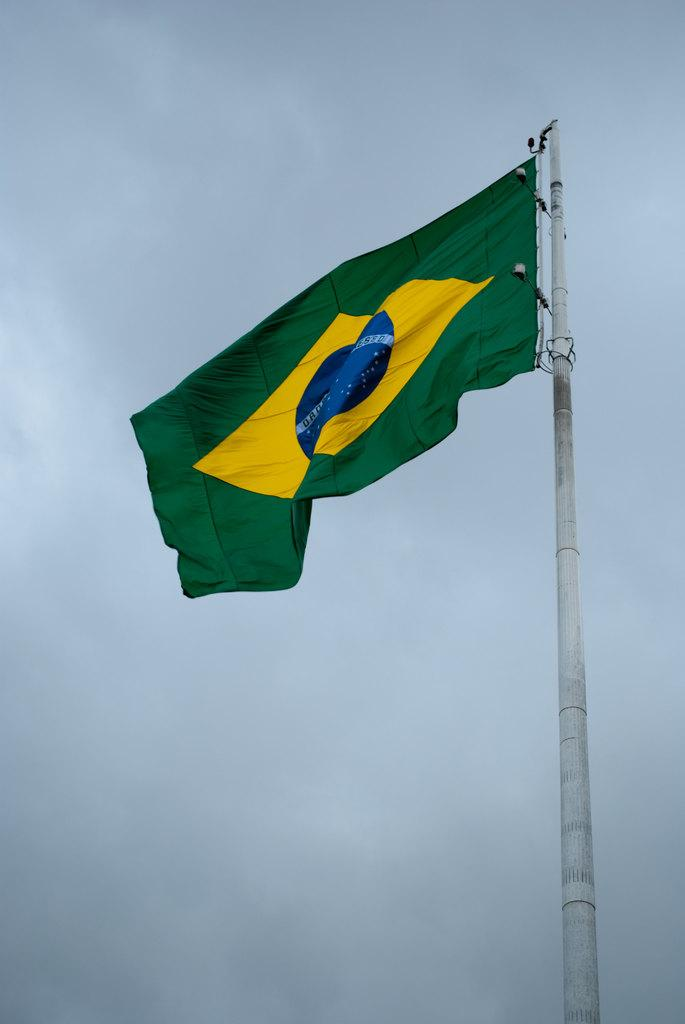What is the main object in the image? There is a flag in the image. What is the flag attached to? The flag is attached to a pole in the image. What colors can be seen on the flag? The flag has green, yellow, and blue colors. What type of joke is being told by the flag in the image? There is no joke being told by the flag in the image; it is simply a flag with colors and attached to a pole. 